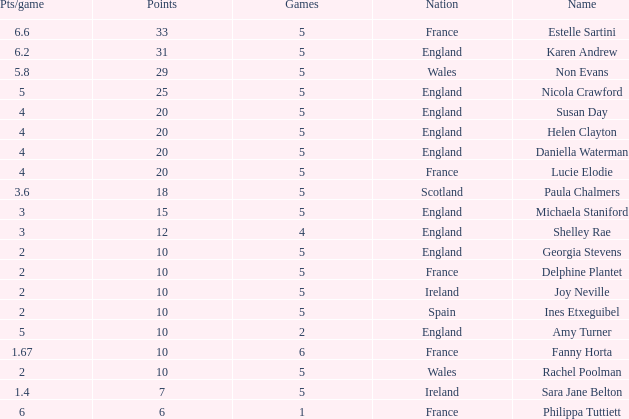Can you tell me the lowest Games that has the Pts/game larger than 1.4 and the Points of 20, and the Name of susan day? 5.0. 